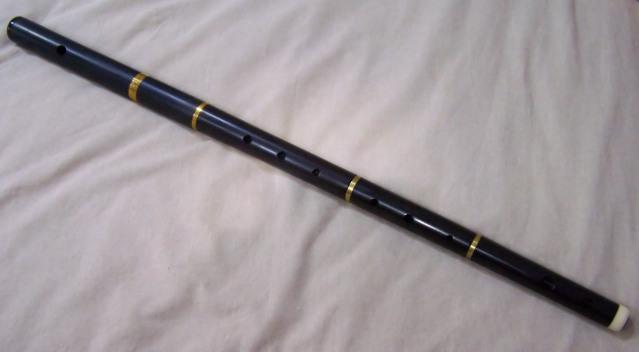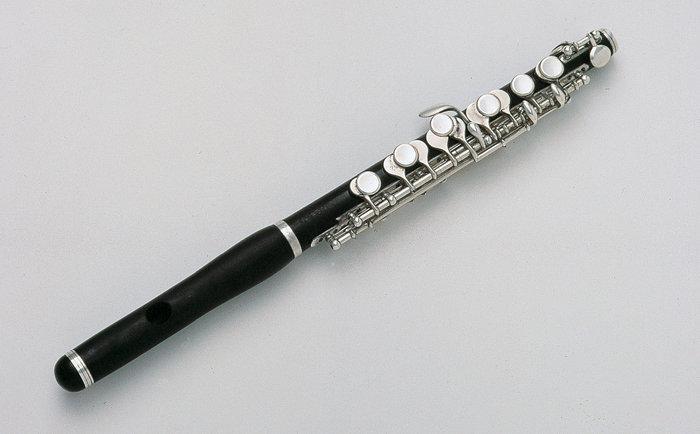The first image is the image on the left, the second image is the image on the right. Given the left and right images, does the statement "There are exactly two instruments in total." hold true? Answer yes or no. Yes. The first image is the image on the left, the second image is the image on the right. For the images shown, is this caption "The left image contains twice as many flutes as the right image." true? Answer yes or no. No. 